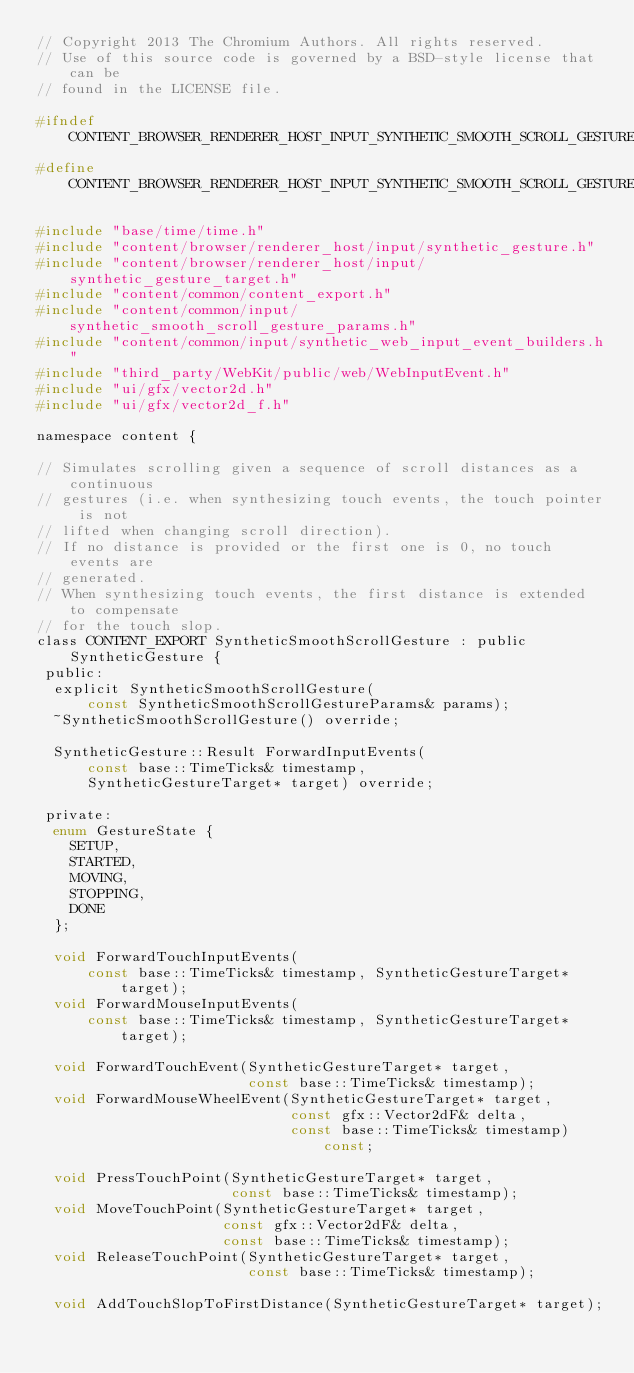<code> <loc_0><loc_0><loc_500><loc_500><_C_>// Copyright 2013 The Chromium Authors. All rights reserved.
// Use of this source code is governed by a BSD-style license that can be
// found in the LICENSE file.

#ifndef CONTENT_BROWSER_RENDERER_HOST_INPUT_SYNTHETIC_SMOOTH_SCROLL_GESTURE_H_
#define CONTENT_BROWSER_RENDERER_HOST_INPUT_SYNTHETIC_SMOOTH_SCROLL_GESTURE_H_

#include "base/time/time.h"
#include "content/browser/renderer_host/input/synthetic_gesture.h"
#include "content/browser/renderer_host/input/synthetic_gesture_target.h"
#include "content/common/content_export.h"
#include "content/common/input/synthetic_smooth_scroll_gesture_params.h"
#include "content/common/input/synthetic_web_input_event_builders.h"
#include "third_party/WebKit/public/web/WebInputEvent.h"
#include "ui/gfx/vector2d.h"
#include "ui/gfx/vector2d_f.h"

namespace content {

// Simulates scrolling given a sequence of scroll distances as a continuous
// gestures (i.e. when synthesizing touch events, the touch pointer is not
// lifted when changing scroll direction).
// If no distance is provided or the first one is 0, no touch events are
// generated.
// When synthesizing touch events, the first distance is extended to compensate
// for the touch slop.
class CONTENT_EXPORT SyntheticSmoothScrollGesture : public SyntheticGesture {
 public:
  explicit SyntheticSmoothScrollGesture(
      const SyntheticSmoothScrollGestureParams& params);
  ~SyntheticSmoothScrollGesture() override;

  SyntheticGesture::Result ForwardInputEvents(
      const base::TimeTicks& timestamp,
      SyntheticGestureTarget* target) override;

 private:
  enum GestureState {
    SETUP,
    STARTED,
    MOVING,
    STOPPING,
    DONE
  };

  void ForwardTouchInputEvents(
      const base::TimeTicks& timestamp, SyntheticGestureTarget* target);
  void ForwardMouseInputEvents(
      const base::TimeTicks& timestamp, SyntheticGestureTarget* target);

  void ForwardTouchEvent(SyntheticGestureTarget* target,
                         const base::TimeTicks& timestamp);
  void ForwardMouseWheelEvent(SyntheticGestureTarget* target,
                              const gfx::Vector2dF& delta,
                              const base::TimeTicks& timestamp) const;

  void PressTouchPoint(SyntheticGestureTarget* target,
                       const base::TimeTicks& timestamp);
  void MoveTouchPoint(SyntheticGestureTarget* target,
                      const gfx::Vector2dF& delta,
                      const base::TimeTicks& timestamp);
  void ReleaseTouchPoint(SyntheticGestureTarget* target,
                         const base::TimeTicks& timestamp);

  void AddTouchSlopToFirstDistance(SyntheticGestureTarget* target);</code> 